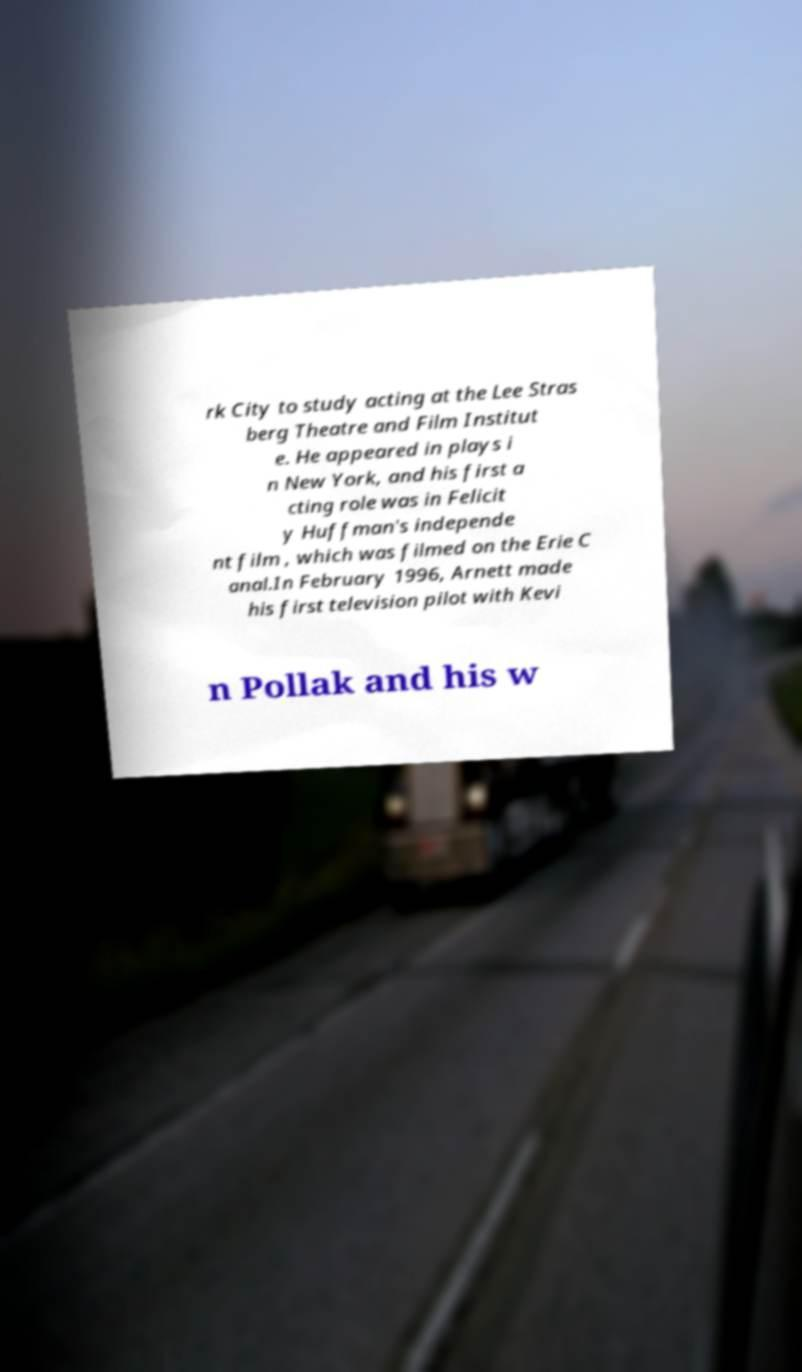Can you accurately transcribe the text from the provided image for me? rk City to study acting at the Lee Stras berg Theatre and Film Institut e. He appeared in plays i n New York, and his first a cting role was in Felicit y Huffman's independe nt film , which was filmed on the Erie C anal.In February 1996, Arnett made his first television pilot with Kevi n Pollak and his w 